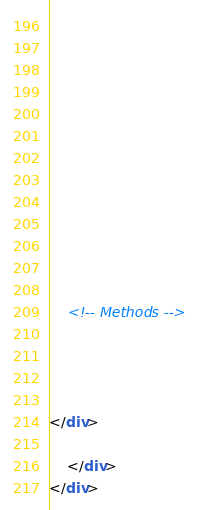Convert code to text. <code><loc_0><loc_0><loc_500><loc_500><_HTML_>  

  

  
    

    

    

    

    <!-- Methods -->
    
    
    
  
</div>

    </div>
</div>
</code> 